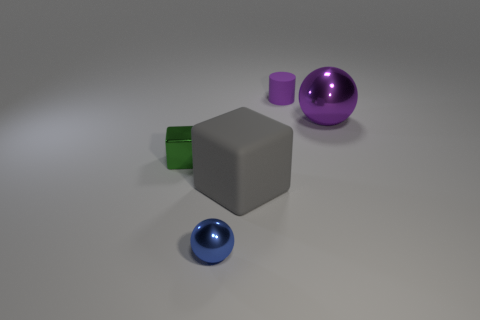Add 1 tiny green metal balls. How many objects exist? 6 Subtract all cylinders. How many objects are left? 4 Subtract all tiny yellow matte blocks. Subtract all cylinders. How many objects are left? 4 Add 3 green metal things. How many green metal things are left? 4 Add 5 small purple spheres. How many small purple spheres exist? 5 Subtract 1 purple spheres. How many objects are left? 4 